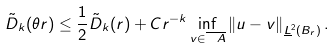Convert formula to latex. <formula><loc_0><loc_0><loc_500><loc_500>\tilde { D } _ { k } ( \theta r ) \leq \frac { 1 } { 2 } \tilde { D } _ { k } ( r ) + C r ^ { - k } \inf _ { v \in \overline { \ A } } \left \| u - v \right \| _ { \underline { L } ^ { 2 } ( B _ { r } ) } .</formula> 